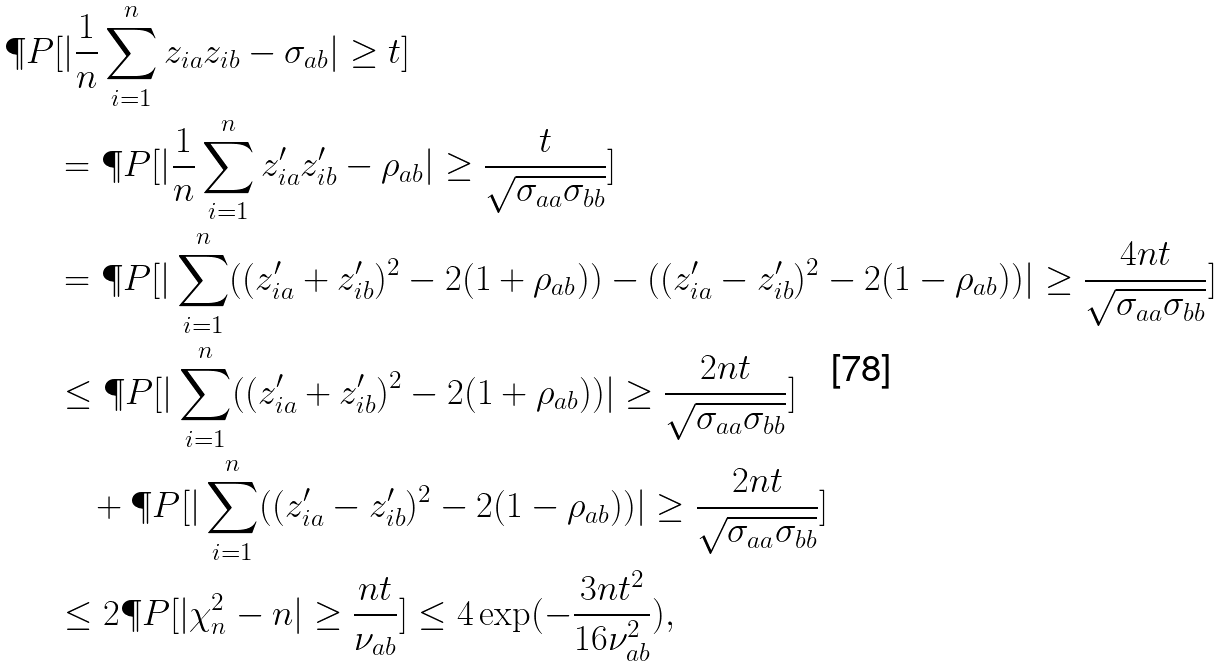Convert formula to latex. <formula><loc_0><loc_0><loc_500><loc_500>\P P & [ | \frac { 1 } { n } \sum _ { i = 1 } ^ { n } z _ { i a } z _ { i b } - \sigma _ { a b } | \geq t ] \\ & = \P P [ | \frac { 1 } { n } \sum _ { i = 1 } ^ { n } z ^ { \prime } _ { i a } z ^ { \prime } _ { i b } - \rho _ { a b } | \geq \frac { t } { \sqrt { \sigma _ { a a } \sigma _ { b b } } } ] \\ & = \P P [ | \sum _ { i = 1 } ^ { n } ( ( z ^ { \prime } _ { i a } + z ^ { \prime } _ { i b } ) ^ { 2 } - 2 ( 1 + \rho _ { a b } ) ) - ( ( z ^ { \prime } _ { i a } - z ^ { \prime } _ { i b } ) ^ { 2 } - 2 ( 1 - \rho _ { a b } ) ) | \geq \frac { 4 n t } { \sqrt { \sigma _ { a a } \sigma _ { b b } } } ] \\ & \leq \P P [ | \sum _ { i = 1 } ^ { n } ( ( z ^ { \prime } _ { i a } + z ^ { \prime } _ { i b } ) ^ { 2 } - 2 ( 1 + \rho _ { a b } ) ) | \geq \frac { 2 n t } { \sqrt { \sigma _ { a a } \sigma _ { b b } } } ] \\ & \quad + \P P [ | \sum _ { i = 1 } ^ { n } ( ( z ^ { \prime } _ { i a } - z ^ { \prime } _ { i b } ) ^ { 2 } - 2 ( 1 - \rho _ { a b } ) ) | \geq \frac { 2 n t } { \sqrt { \sigma _ { a a } \sigma _ { b b } } } ] \\ & \leq 2 \P P [ | \chi ^ { 2 } _ { n } - n | \geq \frac { n t } { \nu _ { a b } } ] \leq 4 \exp ( - \frac { 3 n t ^ { 2 } } { 1 6 \nu _ { a b } ^ { 2 } } ) ,</formula> 